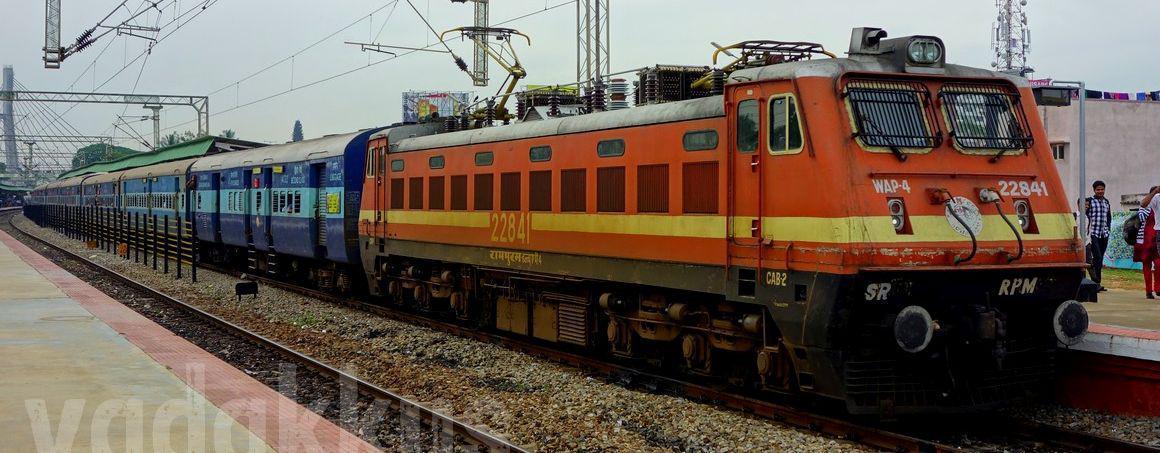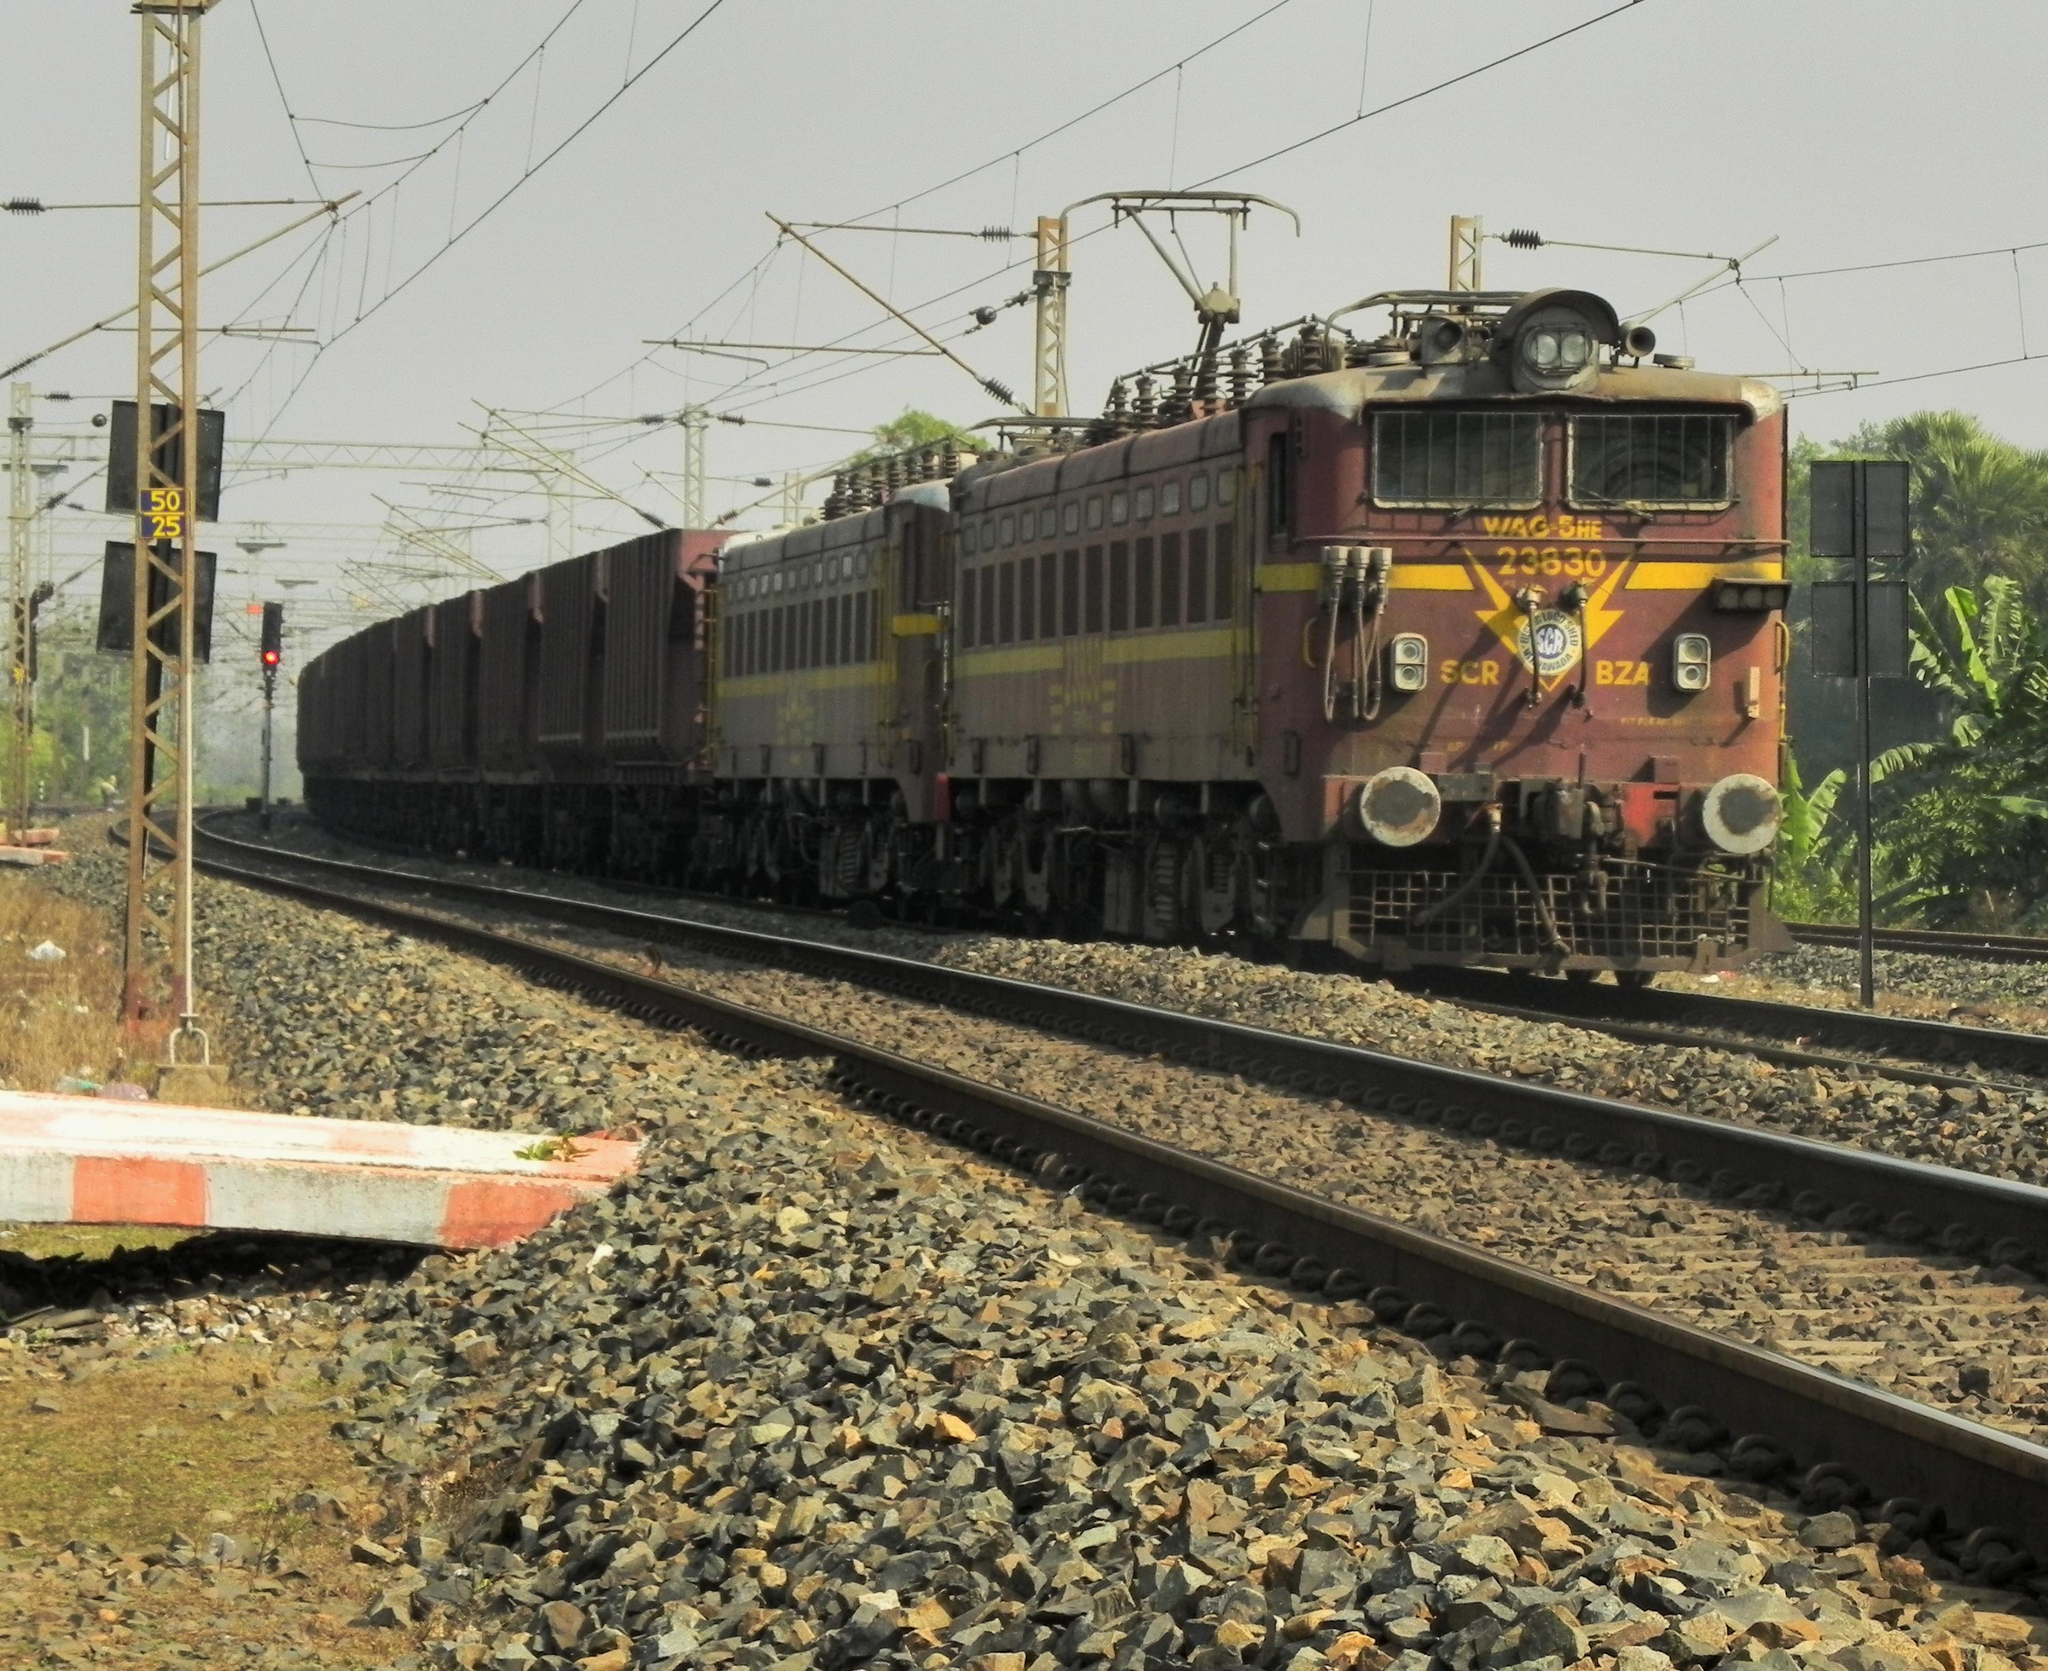The first image is the image on the left, the second image is the image on the right. Considering the images on both sides, is "The red locomotive is pulling other train cars on the railroad tracks." valid? Answer yes or no. Yes. The first image is the image on the left, the second image is the image on the right. Given the left and right images, does the statement "Two trains are heading toward the right." hold true? Answer yes or no. Yes. 